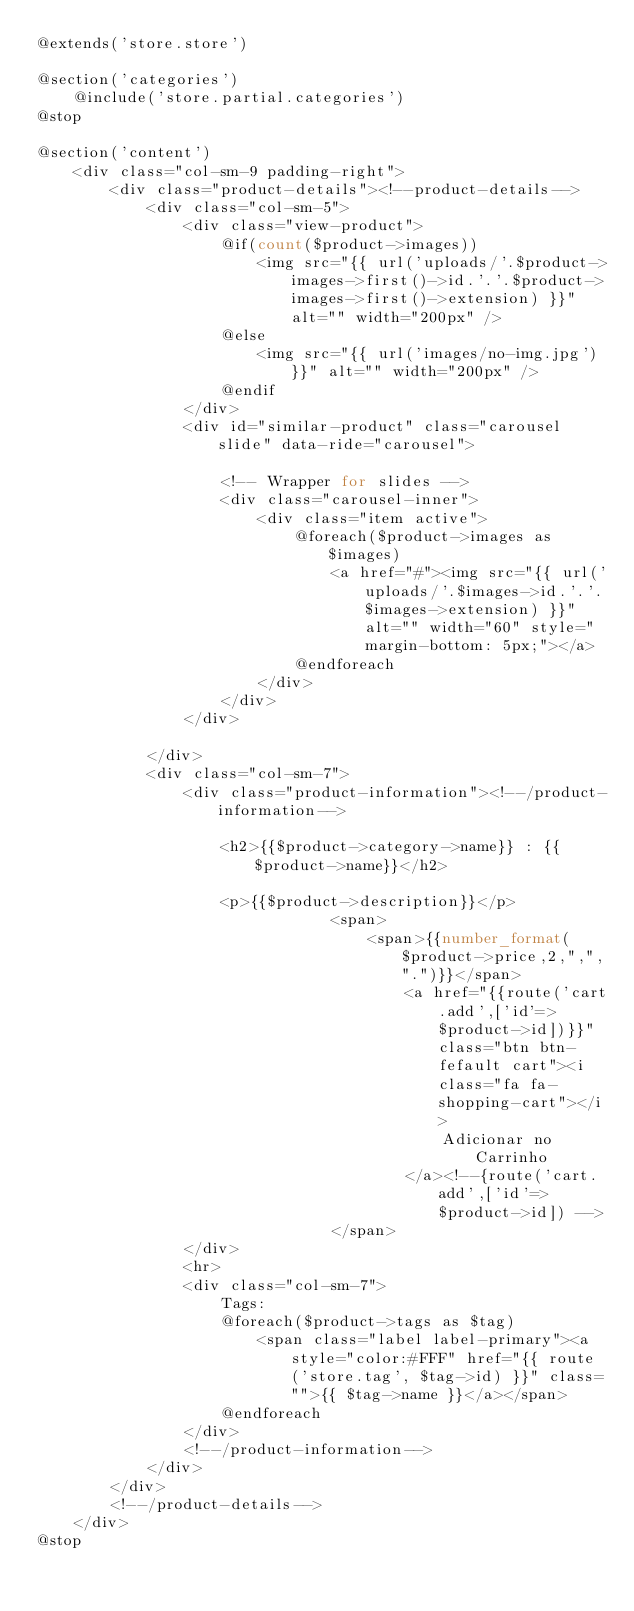Convert code to text. <code><loc_0><loc_0><loc_500><loc_500><_PHP_>@extends('store.store')

@section('categories')
    @include('store.partial.categories')
@stop

@section('content')
    <div class="col-sm-9 padding-right">
        <div class="product-details"><!--product-details-->
            <div class="col-sm-5">
                <div class="view-product">
                    @if(count($product->images))
                        <img src="{{ url('uploads/'.$product->images->first()->id.'.'.$product->images->first()->extension) }}" alt="" width="200px" />
                    @else
                        <img src="{{ url('images/no-img.jpg') }}" alt="" width="200px" />
                    @endif
                </div>
                <div id="similar-product" class="carousel slide" data-ride="carousel">

                    <!-- Wrapper for slides -->
                    <div class="carousel-inner">
                        <div class="item active">
                            @foreach($product->images as $images)
                                <a href="#"><img src="{{ url('uploads/'.$images->id.'.'.$images->extension) }}" alt="" width="60" style="margin-bottom: 5px;"></a>
                            @endforeach
                        </div>
                    </div>
                </div>

            </div>
            <div class="col-sm-7">
                <div class="product-information"><!--/product-information-->

                    <h2>{{$product->category->name}} : {{$product->name}}</h2>

                    <p>{{$product->description}}</p>
                                <span>
                                    <span>{{number_format($product->price,2,",",".")}}</span>
                                        <a href="{{route('cart.add',['id'=>$product->id])}}" class="btn btn-fefault cart"><i class="fa fa-shopping-cart"></i>
                                            Adicionar no Carrinho
                                        </a><!--{route('cart.add',['id'=>$product->id]) -->
                                </span>
                </div>
                <hr>
                <div class="col-sm-7">
                    Tags:
                    @foreach($product->tags as $tag)
                        <span class="label label-primary"><a style="color:#FFF" href="{{ route('store.tag', $tag->id) }}" class="">{{ $tag->name }}</a></span>
                    @endforeach
                </div>
                <!--/product-information-->
            </div>
        </div>
        <!--/product-details-->
    </div>
@stop</code> 